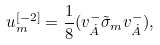Convert formula to latex. <formula><loc_0><loc_0><loc_500><loc_500>u _ { m } ^ { [ - 2 ] } = { \frac { 1 } { 8 } } ( v _ { \dot { A } } ^ { - } \tilde { \sigma } _ { m } v _ { { \dot { A } } } ^ { - } ) ,</formula> 